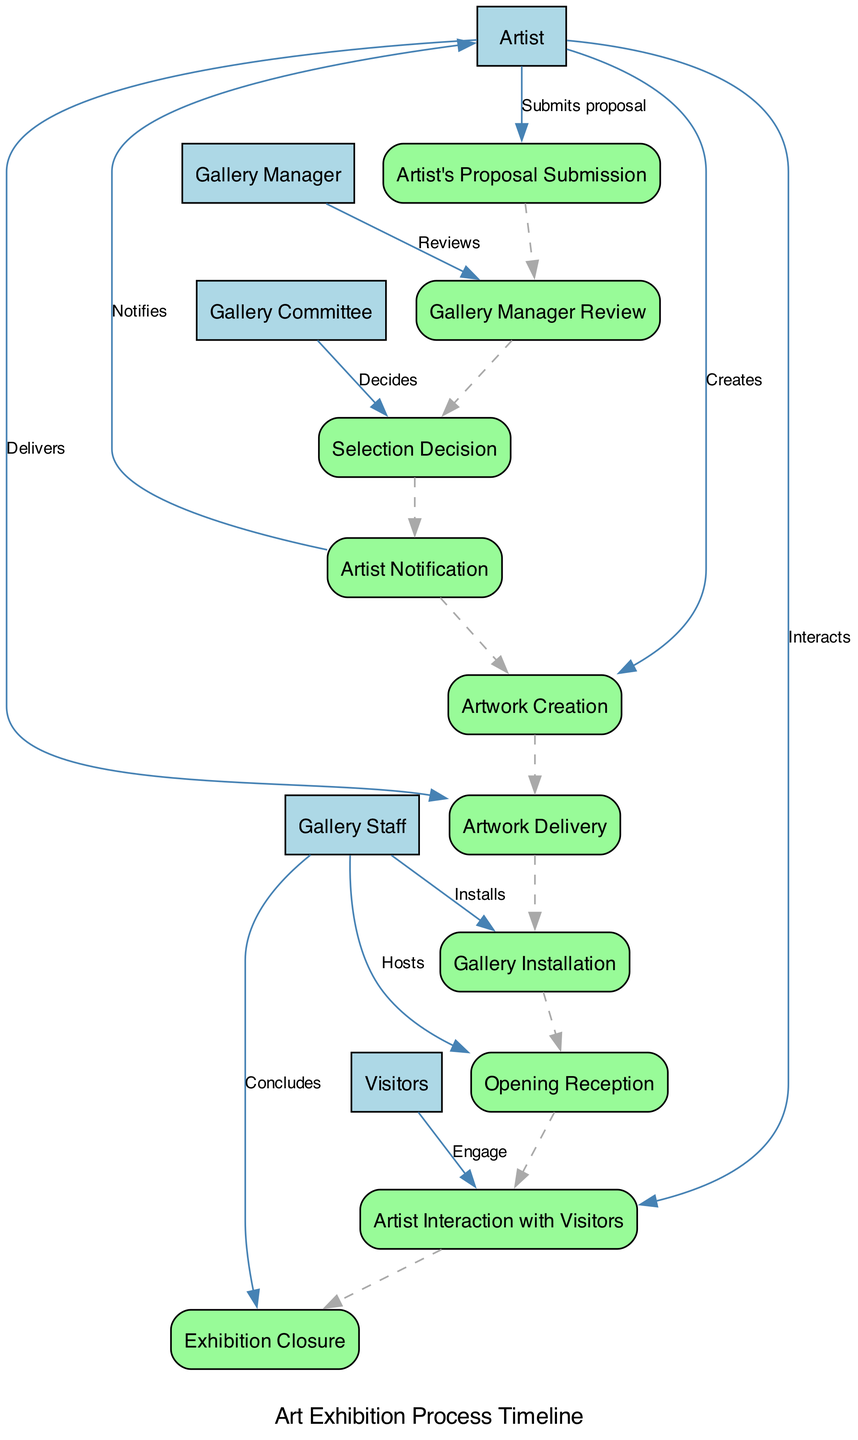What is the first step in the art exhibition process? The first step in the diagram is represented by the node "Artist's Proposal Submission," which indicates the beginning of the process where the artist submits a proposal for an exhibition.
Answer: Artist's Proposal Submission How many steps are involved in the art exhibition process? By counting the nodes in the sequence diagram, we find there are ten distinct steps listed from submission to closure of the exhibition.
Answer: Ten Which participant is responsible for the gallery installation? The "Gallery Staff" is indicated in the diagram as the participant responsible for the "Gallery Installation," which shows their role in setting up the artwork.
Answer: Gallery Staff What does the artist do after receiving the selection decision? After being notified about the selection decision, the artist proceeds to create artworks if their proposal is approved, as shown in the flow of the diagram.
Answer: Artwork Creation Which two steps directly follow the artwork delivery? The diagram shows that "Gallery Installation" directly follows "Artwork Delivery," indicating the next action taken after the artworks are delivered to the gallery.
Answer: Gallery Installation Which step involves community engagement? The "Opening Reception" is specifically noted as the step where community engagement occurs, as the gallery invites the public, critics, and art enthusiasts to attend.
Answer: Opening Reception What happens during the "Artist Interaction with Visitors"? During this step, the artist engages with visitors, sharing insights about their work, which is depicted in the diagram as a form of interaction.
Answer: Shares insights What step concludes the art exhibition process? The final step in the sequence is "Exhibition Closure," which involves wrapping up the exhibition after its duration has ended, as shown in the last node of the diagram.
Answer: Exhibition Closure Which step comes after the artist delivers the artwork? After "Artwork Delivery," the next step in the sequence is "Gallery Installation," where the staff sets up the exhibition.
Answer: Gallery Installation How many participants are involved in the art exhibition process? The diagram includes five distinct participants: Artist, Gallery Manager, Gallery Committee, Gallery Staff, and Visitors, which contribute to the process's flow.
Answer: Five 